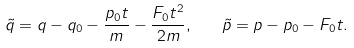Convert formula to latex. <formula><loc_0><loc_0><loc_500><loc_500>\tilde { q } = q - q _ { 0 } - \frac { p _ { 0 } t } { m } - \frac { F _ { 0 } t ^ { 2 } } { 2 m } , \quad \tilde { p } = p - p _ { 0 } - F _ { 0 } t .</formula> 